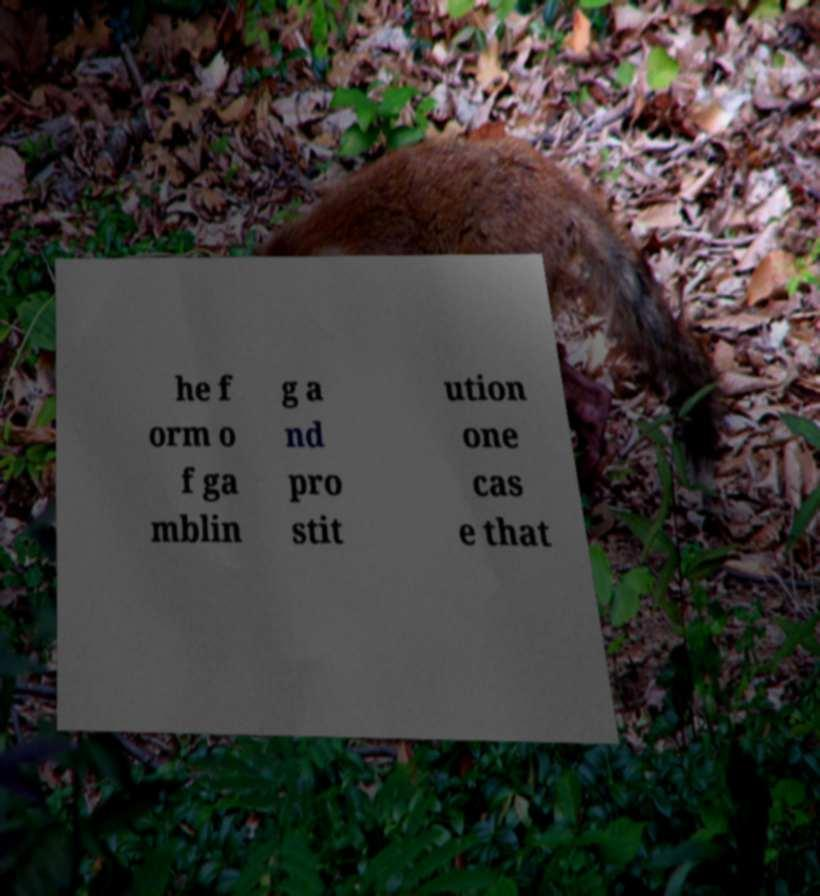Could you assist in decoding the text presented in this image and type it out clearly? he f orm o f ga mblin g a nd pro stit ution one cas e that 